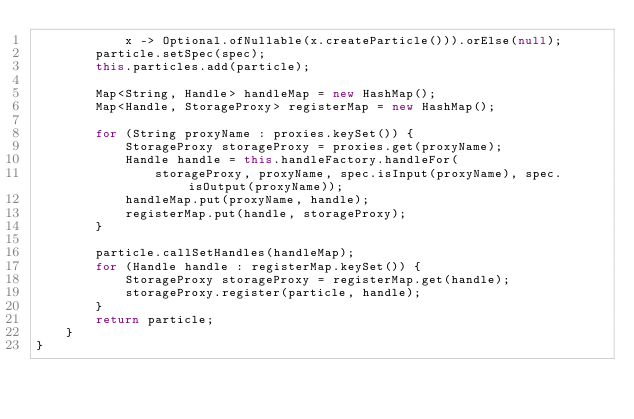<code> <loc_0><loc_0><loc_500><loc_500><_Java_>            x -> Optional.ofNullable(x.createParticle())).orElse(null);
        particle.setSpec(spec);
        this.particles.add(particle);

        Map<String, Handle> handleMap = new HashMap();
        Map<Handle, StorageProxy> registerMap = new HashMap();

        for (String proxyName : proxies.keySet()) {
            StorageProxy storageProxy = proxies.get(proxyName);
            Handle handle = this.handleFactory.handleFor(
                storageProxy, proxyName, spec.isInput(proxyName), spec.isOutput(proxyName));
            handleMap.put(proxyName, handle);
            registerMap.put(handle, storageProxy);
        }

        particle.callSetHandles(handleMap);
        for (Handle handle : registerMap.keySet()) {
            StorageProxy storageProxy = registerMap.get(handle);
            storageProxy.register(particle, handle);
        }
        return particle;
    }
}
</code> 